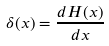Convert formula to latex. <formula><loc_0><loc_0><loc_500><loc_500>\delta ( x ) = \frac { d H ( x ) } { d x }</formula> 